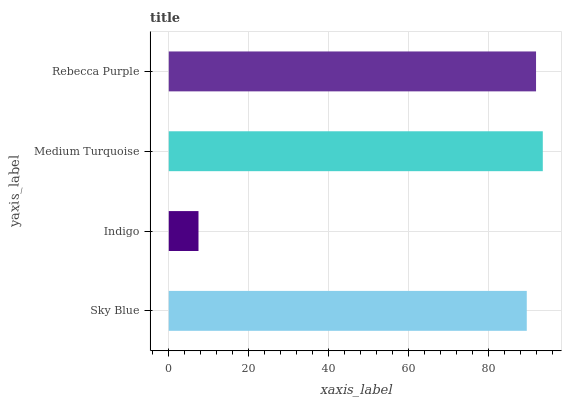Is Indigo the minimum?
Answer yes or no. Yes. Is Medium Turquoise the maximum?
Answer yes or no. Yes. Is Medium Turquoise the minimum?
Answer yes or no. No. Is Indigo the maximum?
Answer yes or no. No. Is Medium Turquoise greater than Indigo?
Answer yes or no. Yes. Is Indigo less than Medium Turquoise?
Answer yes or no. Yes. Is Indigo greater than Medium Turquoise?
Answer yes or no. No. Is Medium Turquoise less than Indigo?
Answer yes or no. No. Is Rebecca Purple the high median?
Answer yes or no. Yes. Is Sky Blue the low median?
Answer yes or no. Yes. Is Sky Blue the high median?
Answer yes or no. No. Is Medium Turquoise the low median?
Answer yes or no. No. 